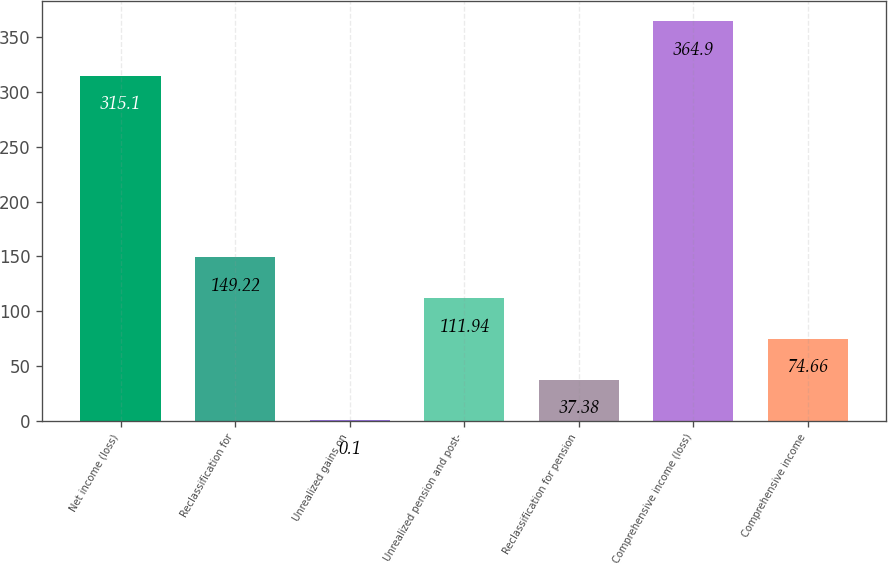<chart> <loc_0><loc_0><loc_500><loc_500><bar_chart><fcel>Net income (loss)<fcel>Reclassification for<fcel>Unrealized gains on<fcel>Unrealized pension and post-<fcel>Reclassification for pension<fcel>Comprehensive income (loss)<fcel>Comprehensive income<nl><fcel>315.1<fcel>149.22<fcel>0.1<fcel>111.94<fcel>37.38<fcel>364.9<fcel>74.66<nl></chart> 